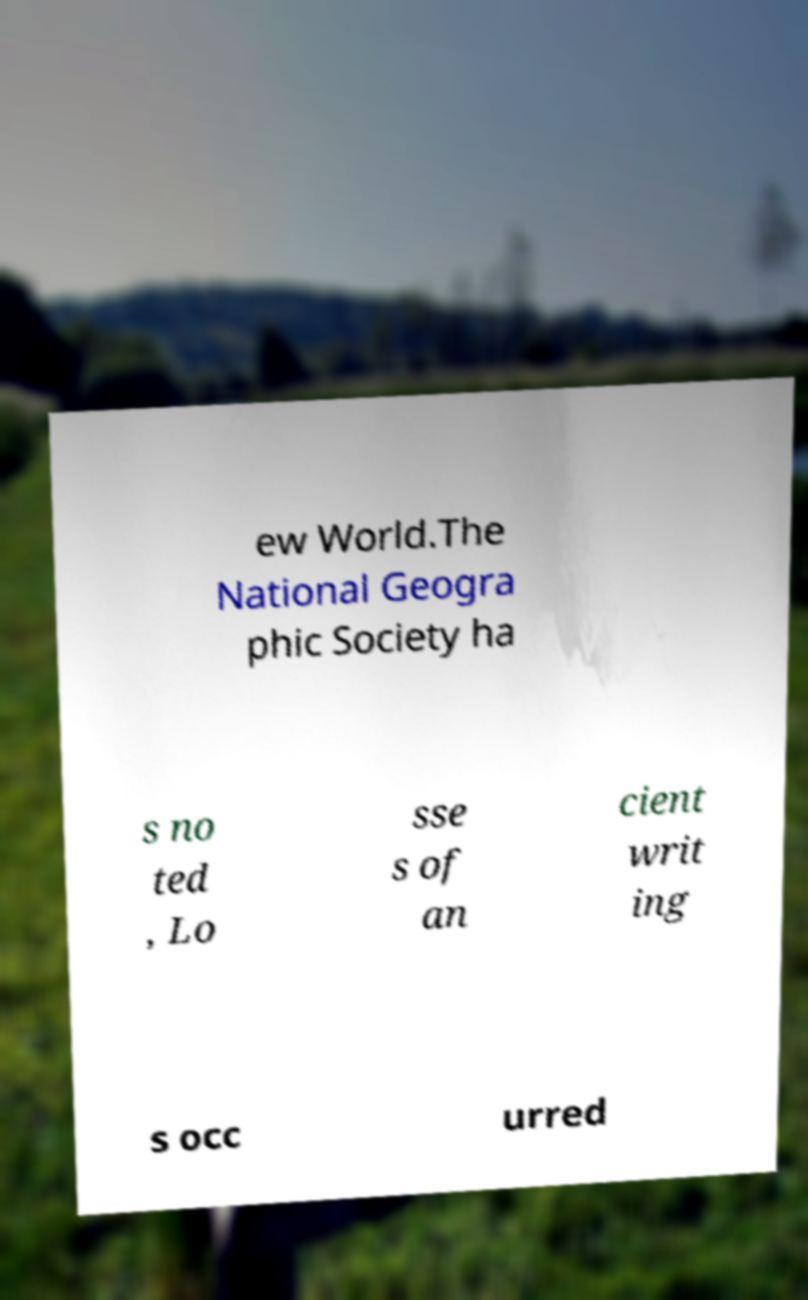Can you read and provide the text displayed in the image?This photo seems to have some interesting text. Can you extract and type it out for me? ew World.The National Geogra phic Society ha s no ted , Lo sse s of an cient writ ing s occ urred 